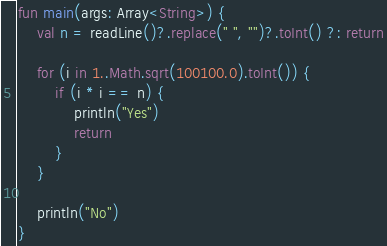<code> <loc_0><loc_0><loc_500><loc_500><_Kotlin_>fun main(args: Array<String>) {
    val n = readLine()?.replace(" ", "")?.toInt() ?: return

    for (i in 1..Math.sqrt(100100.0).toInt()) {
        if (i * i == n) {
            println("Yes")
            return
        }
    }

    println("No")
}</code> 